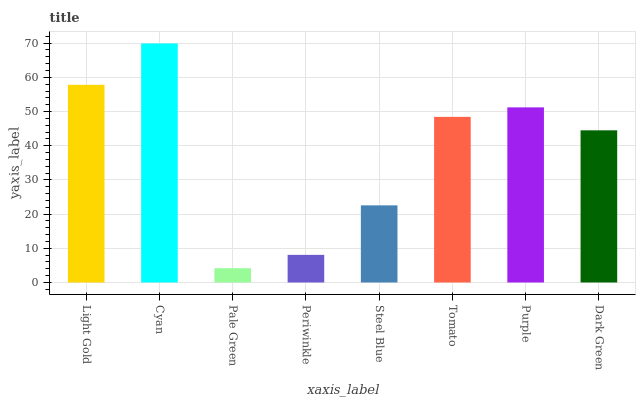Is Pale Green the minimum?
Answer yes or no. Yes. Is Cyan the maximum?
Answer yes or no. Yes. Is Cyan the minimum?
Answer yes or no. No. Is Pale Green the maximum?
Answer yes or no. No. Is Cyan greater than Pale Green?
Answer yes or no. Yes. Is Pale Green less than Cyan?
Answer yes or no. Yes. Is Pale Green greater than Cyan?
Answer yes or no. No. Is Cyan less than Pale Green?
Answer yes or no. No. Is Tomato the high median?
Answer yes or no. Yes. Is Dark Green the low median?
Answer yes or no. Yes. Is Pale Green the high median?
Answer yes or no. No. Is Purple the low median?
Answer yes or no. No. 